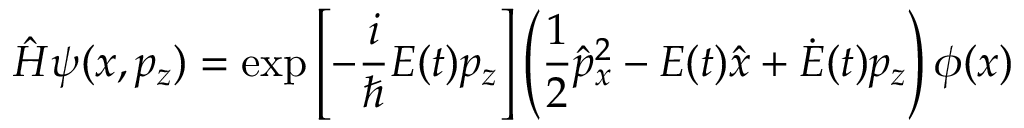<formula> <loc_0><loc_0><loc_500><loc_500>\hat { H } \psi ( x , p _ { z } ) = \exp \left [ - \frac { i } { } E ( t ) p _ { z } \right ] \left ( \frac { 1 } { 2 } \hat { p } _ { x } ^ { 2 } - E ( t ) \hat { x } + \dot { E } ( t ) p _ { z } \right ) \phi ( x )</formula> 